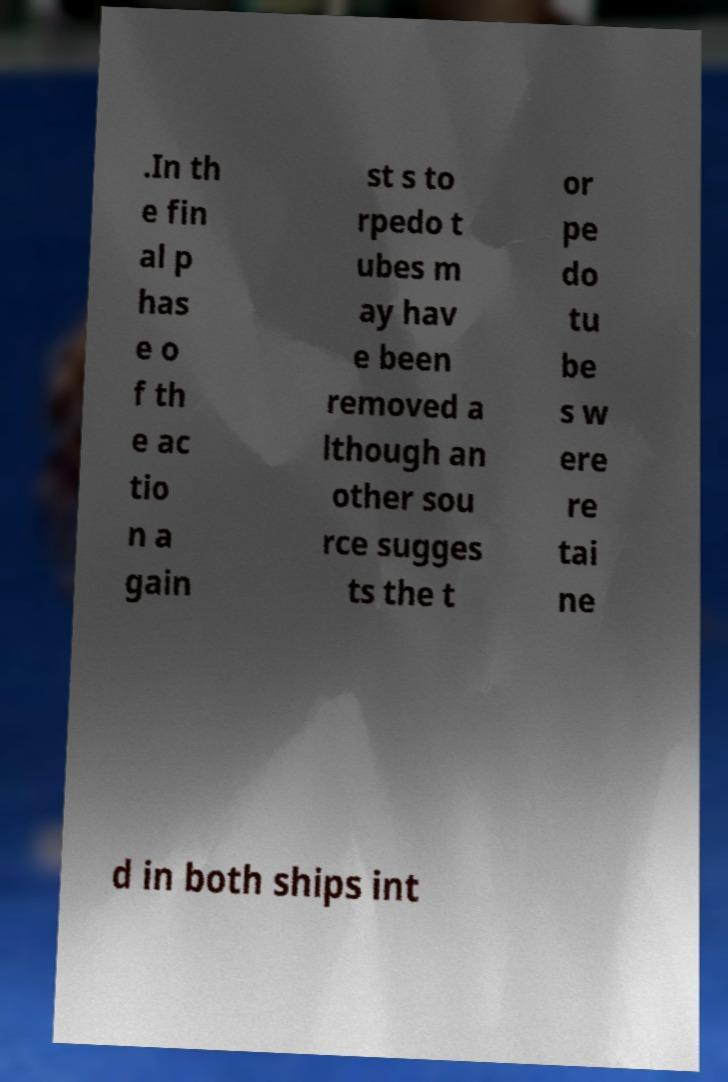I need the written content from this picture converted into text. Can you do that? .In th e fin al p has e o f th e ac tio n a gain st s to rpedo t ubes m ay hav e been removed a lthough an other sou rce sugges ts the t or pe do tu be s w ere re tai ne d in both ships int 